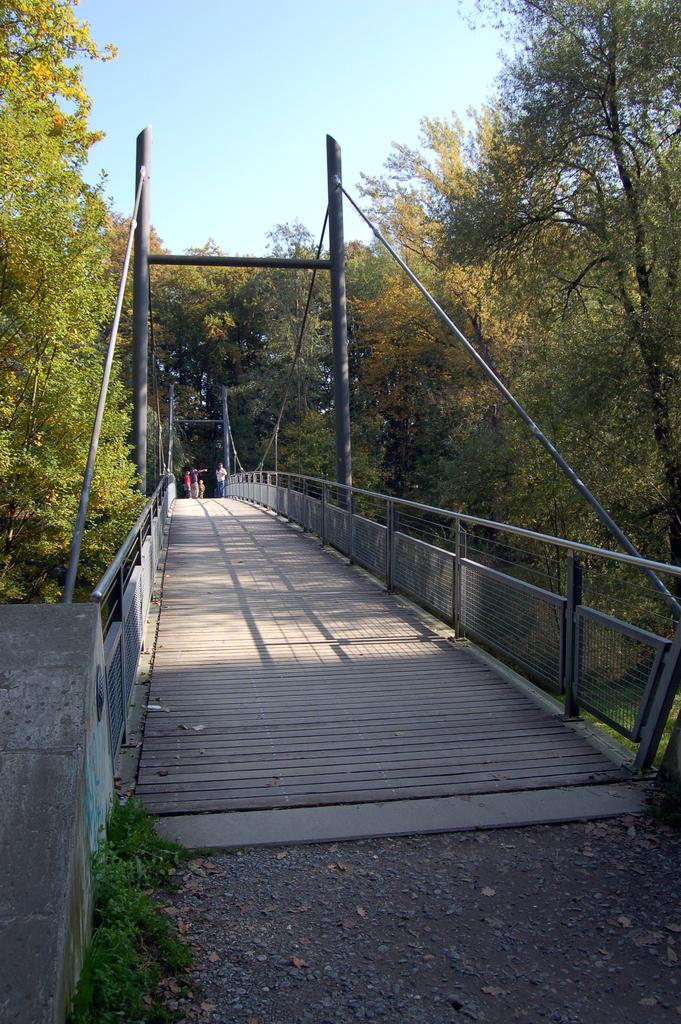What structure is present in the image? There is a bridge in the image. What material is used for the path on the bridge? A: The bridge has a wooden path. What safety feature is present on the bridge? The bridge has railings. What type of vegetation can be seen near the bridge? There are trees on the sides of the bridge. What can be seen in the background of the image? There is sky visible in the background of the image. What type of haircut is the bridge getting in the image? The bridge is not getting a haircut in the image, as it is a structure and not a living being. What material is the tin used for in the image? There is no tin present in the image. 